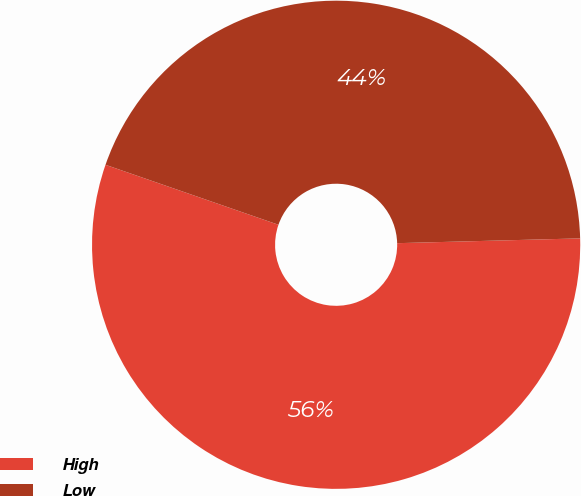Convert chart to OTSL. <chart><loc_0><loc_0><loc_500><loc_500><pie_chart><fcel>High<fcel>Low<nl><fcel>55.73%<fcel>44.27%<nl></chart> 